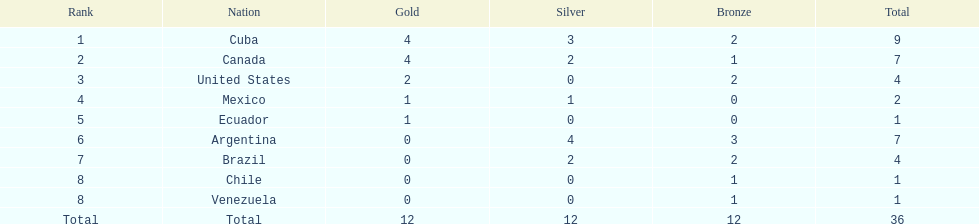Which countries have obtained gold medals? Cuba, Canada, United States, Mexico, Ecuador. Of these countries, which ones have never received silver or bronze medals? United States, Ecuador. Of the two nations listed previously, which one has exclusively won a gold medal? Ecuador. 